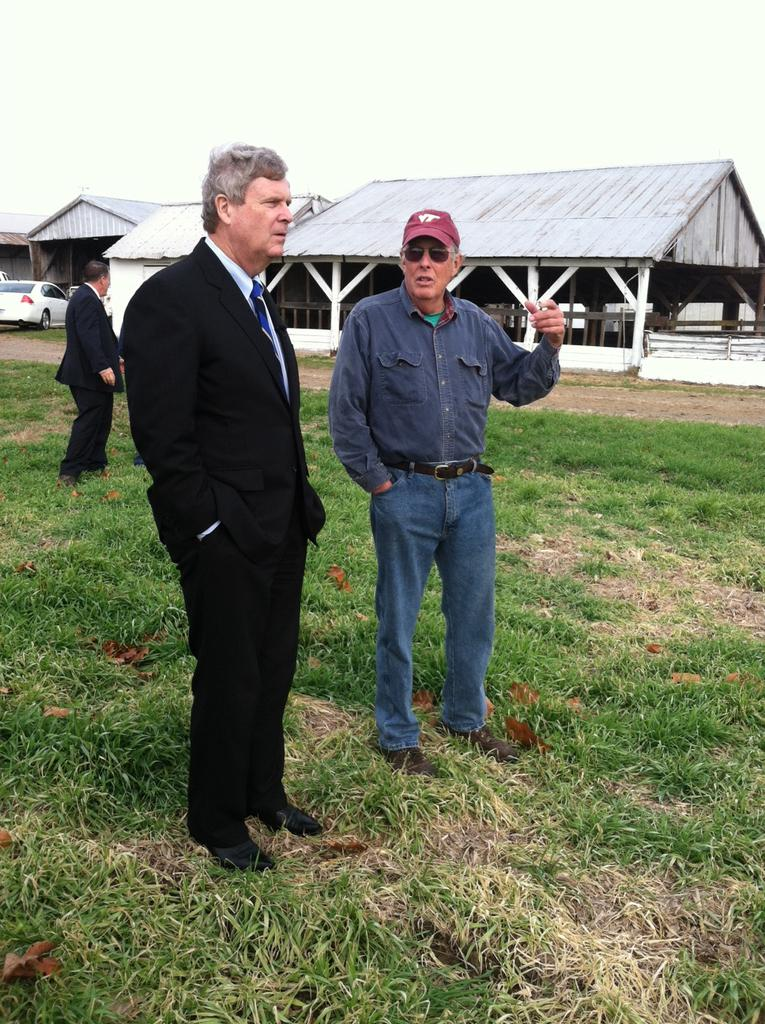How many people are standing on the ground in the image? There are two men standing on the ground in the image. What can be seen in the background of the image? In the background of the image, there is a person, a vehicle, a house, a fence, grass, and sky. Can you describe the setting of the image? The image shows two men standing on the ground, with a background that includes various elements such as a person, a vehicle, a house, a fence, grass, and sky. What type of joke is the person in the background telling in the image? There is no indication in the image that the person in the background is telling a joke, so it cannot be determined from the image. 